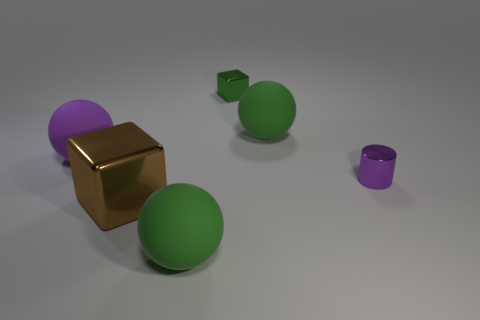There is a big green rubber thing on the right side of the big rubber sphere in front of the large brown object; what number of green metallic objects are in front of it?
Provide a short and direct response. 0. There is a large object that is right of the large brown block and in front of the small purple metal object; what color is it?
Keep it short and to the point. Green. How many small blocks have the same color as the cylinder?
Provide a succinct answer. 0. How many cylinders are small purple shiny things or large green objects?
Give a very brief answer. 1. What is the color of the metal object that is the same size as the purple rubber object?
Ensure brevity in your answer.  Brown. There is a sphere that is right of the large green object to the left of the small shiny block; is there a cylinder that is left of it?
Provide a succinct answer. No. What size is the brown thing?
Your answer should be compact. Large. What number of objects are either purple rubber things or cylinders?
Your response must be concise. 2. What is the color of the small block that is the same material as the tiny purple cylinder?
Give a very brief answer. Green. There is a big rubber object that is behind the large purple thing; is its shape the same as the small purple object?
Your answer should be very brief. No. 